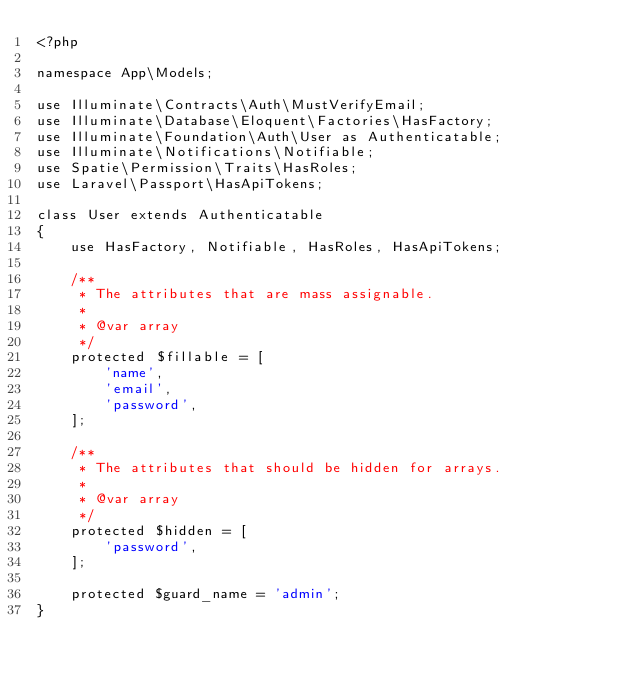Convert code to text. <code><loc_0><loc_0><loc_500><loc_500><_PHP_><?php

namespace App\Models;

use Illuminate\Contracts\Auth\MustVerifyEmail;
use Illuminate\Database\Eloquent\Factories\HasFactory;
use Illuminate\Foundation\Auth\User as Authenticatable;
use Illuminate\Notifications\Notifiable;
use Spatie\Permission\Traits\HasRoles;
use Laravel\Passport\HasApiTokens;

class User extends Authenticatable
{
    use HasFactory, Notifiable, HasRoles, HasApiTokens;

    /**
     * The attributes that are mass assignable.
     *
     * @var array
     */
    protected $fillable = [
        'name',
        'email',
        'password',
    ];

    /**
     * The attributes that should be hidden for arrays.
     *
     * @var array
     */
    protected $hidden = [
        'password',
    ];

    protected $guard_name = 'admin';
}
</code> 